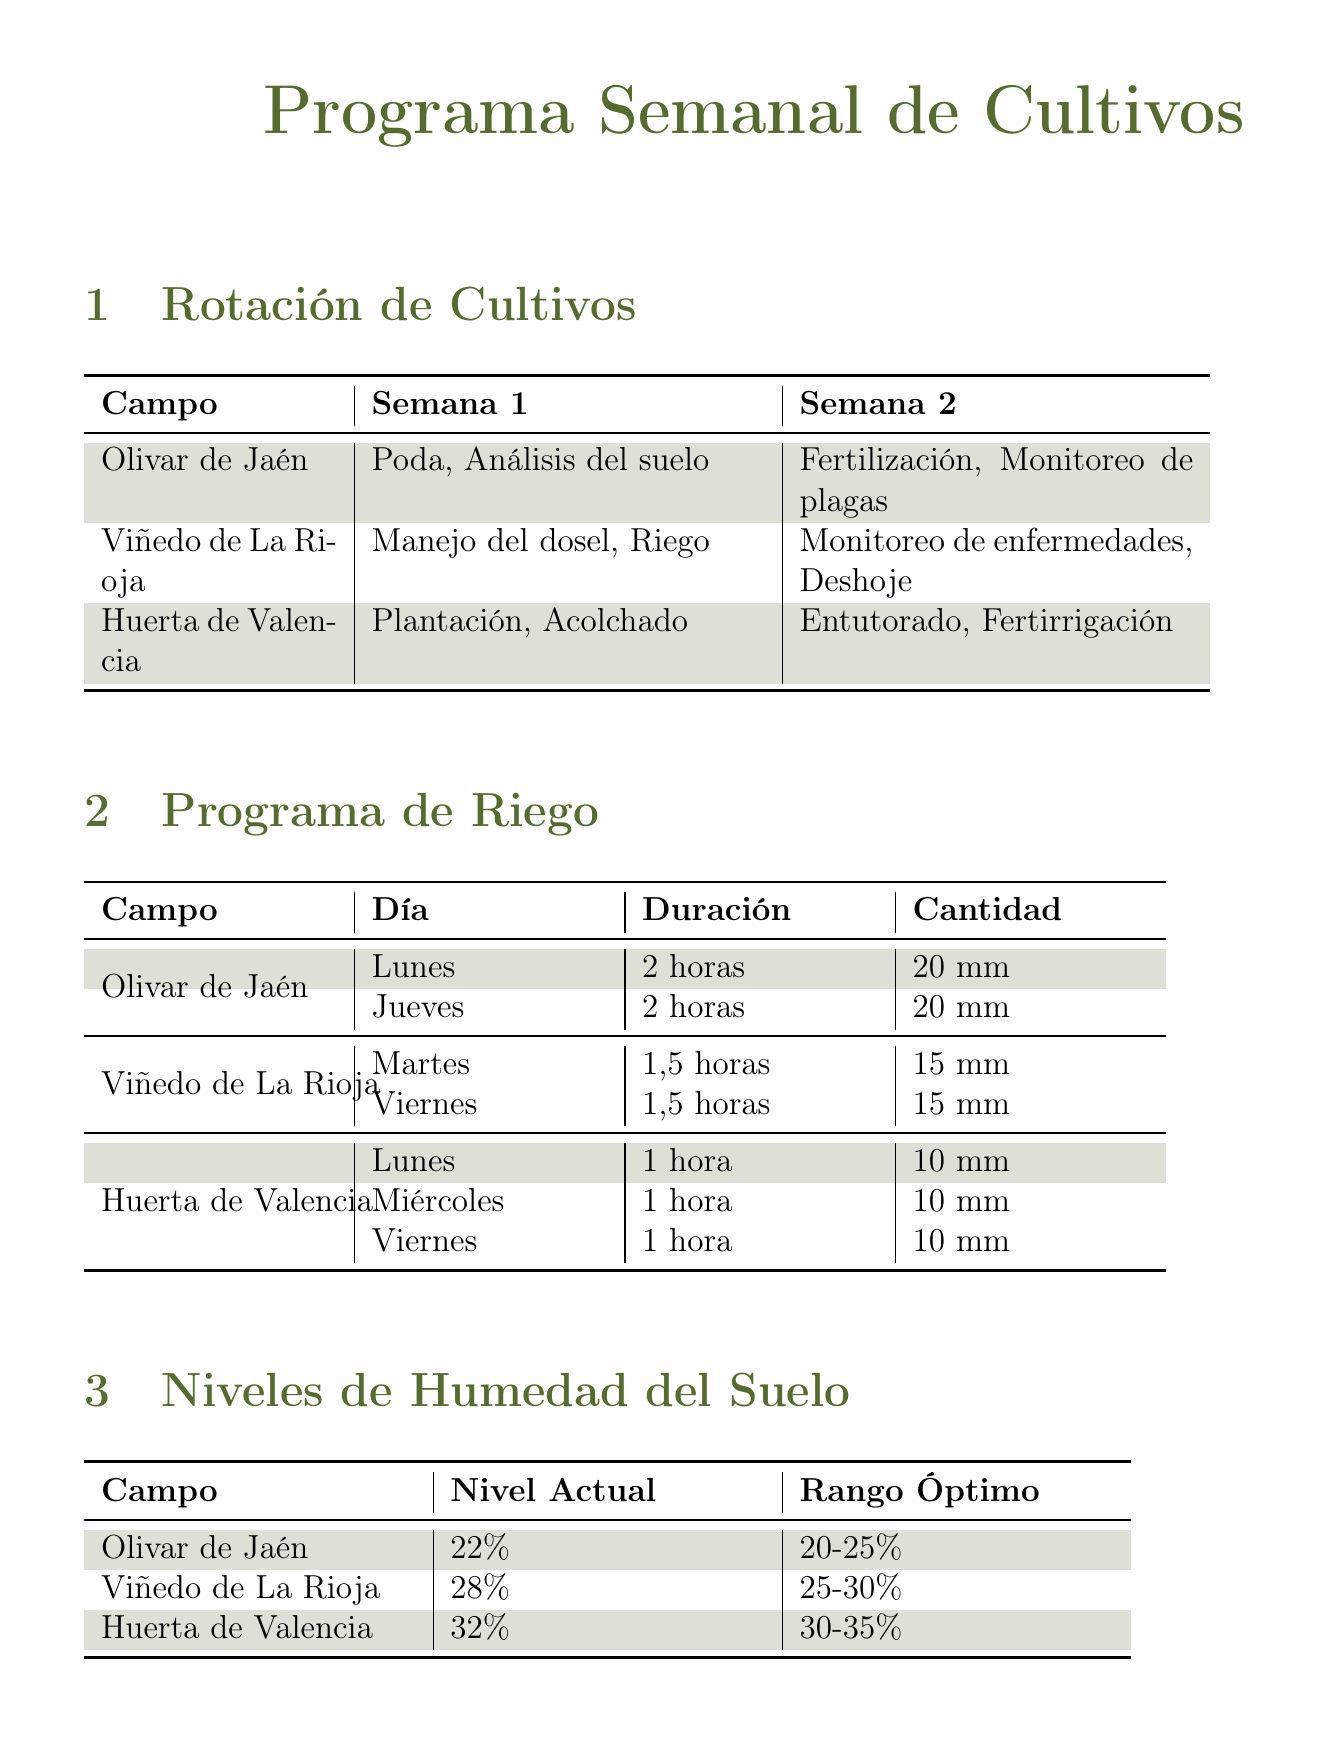What tasks are scheduled for week 1 in Olivar de Jaén? The tasks scheduled for week 1 in Olivar de Jaén include Pruning and Soil analysis.
Answer: Pruning, Soil analysis What is the irrigation duration for Viñedo de La Rioja on Tuesday? The irrigation duration for Viñedo de La Rioja on Tuesday is 1.5 hours.
Answer: 1.5 hours What is the current soil moisture level in Huerta de Valencia? The current soil moisture level in Huerta de Valencia is 32%.
Answer: 32% What is the weather forecast for Thursday? The weather forecast for Thursday includes a temperature of 27°C, precipitation of 30%, and wind speed of 8 km/h.
Answer: 27°C, 30%, 8 km/h Which equipment is scheduled for pest control in Viñedo de La Rioja? The equipment scheduled for pest control in Viñedo de La Rioja is the Sprayer Kuhn Deltis 1302.
Answer: Sprayer Kuhn Deltis 1302 What is the nutrient status of Olivar de Jaén? The nutrient status of Olivar de Jaén is Adequate.
Answer: Adequate What tasks are planned for week 2 in Huerta de Valencia? The tasks planned for week 2 in Huerta de Valencia include Staking and Fertigation.
Answer: Staking, Fertigation What is the optimal soil moisture range for Viñedo de La Rioja? The optimal soil moisture range for Viñedo de La Rioja is 25-30%.
Answer: 25-30% 